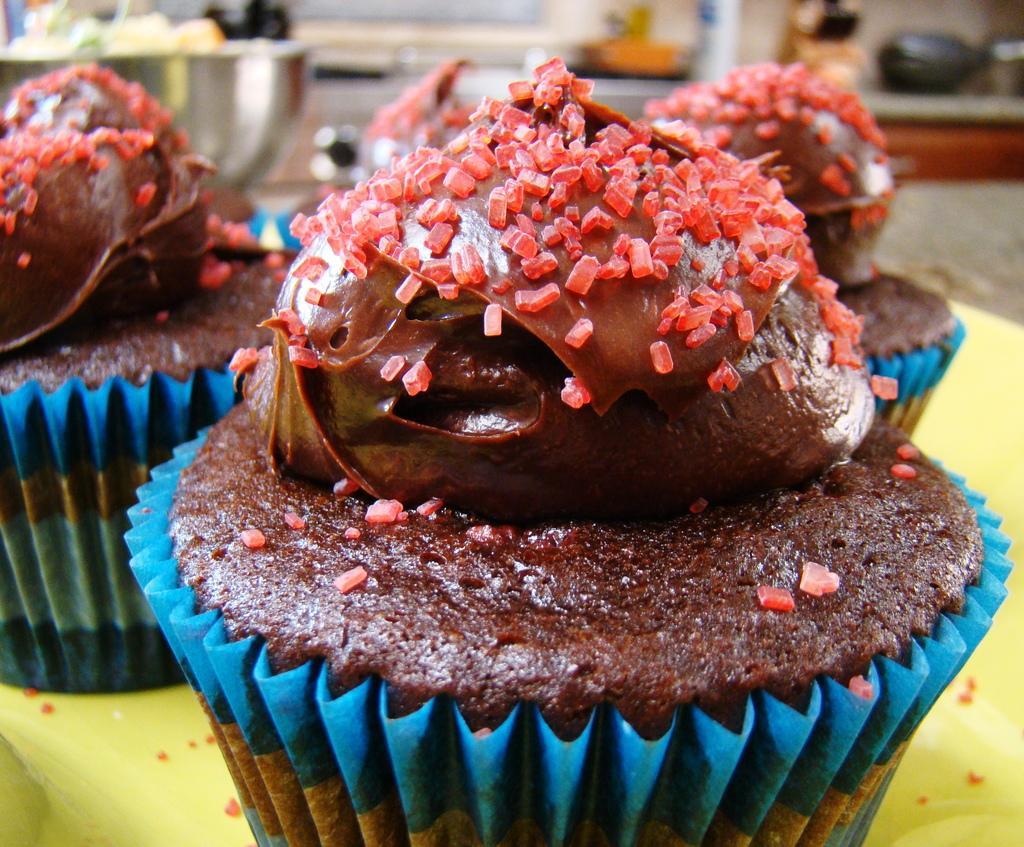Please provide a concise description of this image. In this picture we can see cupcakes with creams on it and in the background we can see some objects and it is blurry. 